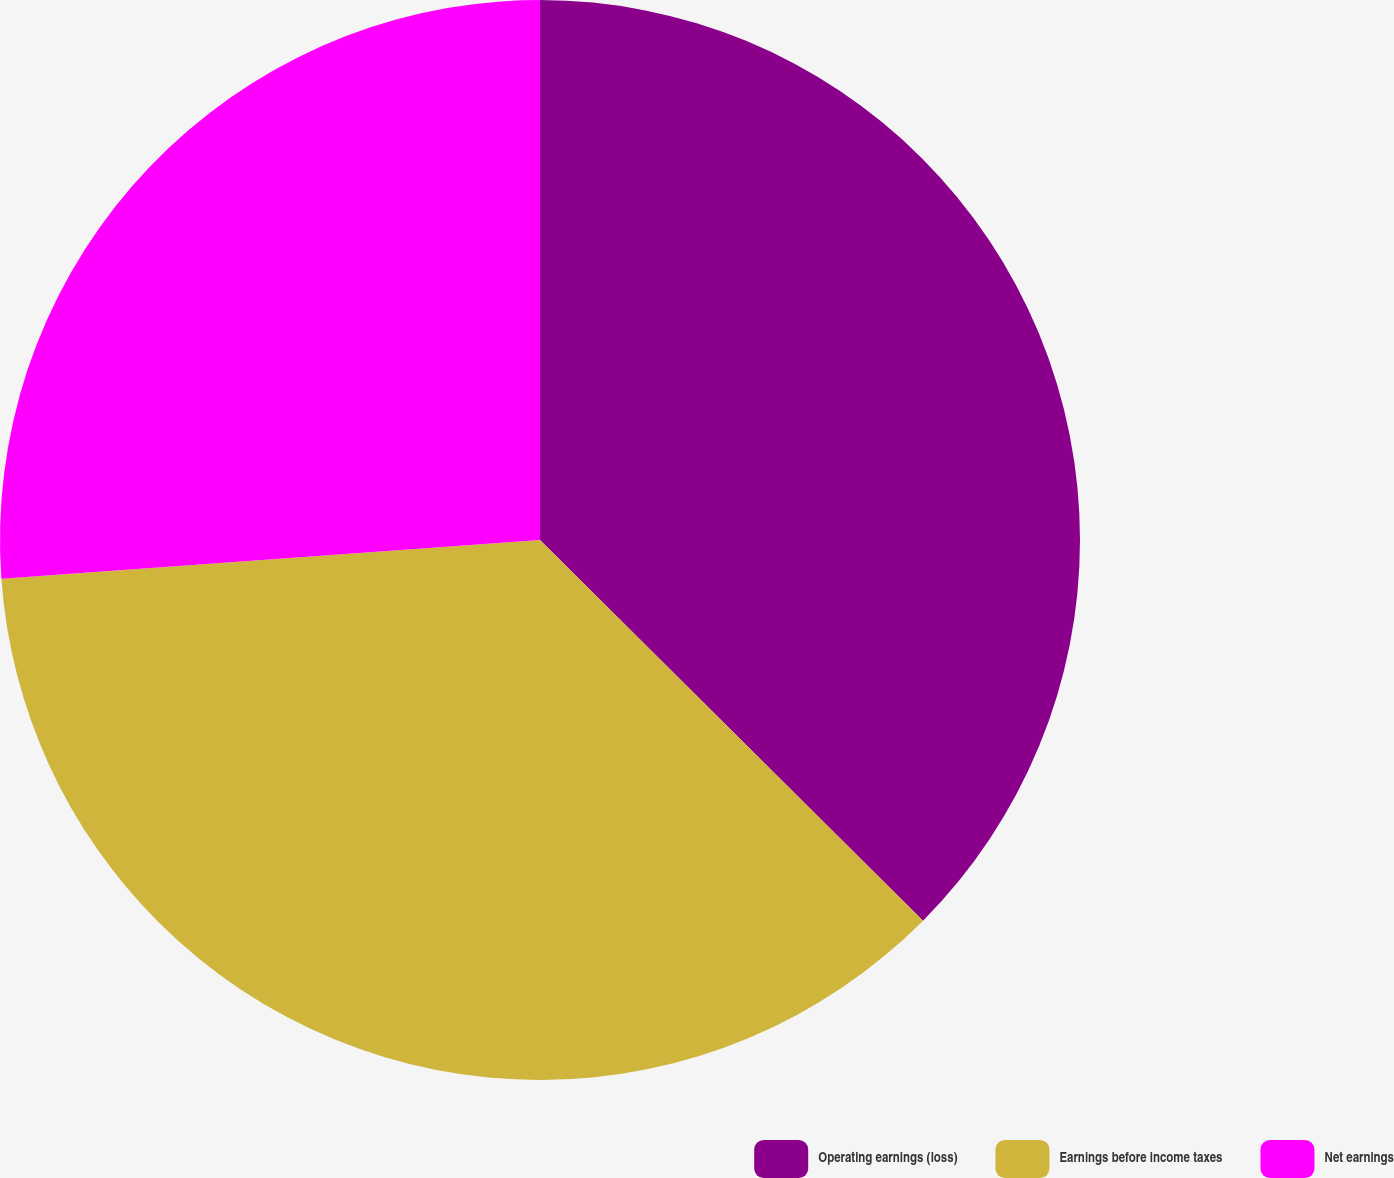Convert chart to OTSL. <chart><loc_0><loc_0><loc_500><loc_500><pie_chart><fcel>Operating earnings (loss)<fcel>Earnings before income taxes<fcel>Net earnings<nl><fcel>37.45%<fcel>36.41%<fcel>26.14%<nl></chart> 